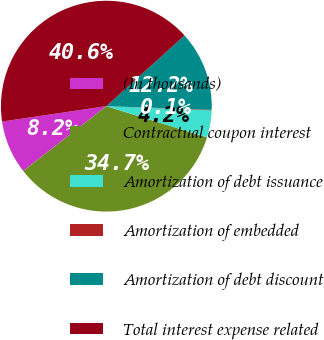Convert chart to OTSL. <chart><loc_0><loc_0><loc_500><loc_500><pie_chart><fcel>(In thousands)<fcel>Contractual coupon interest<fcel>Amortization of debt issuance<fcel>Amortization of embedded<fcel>Amortization of debt discount<fcel>Total interest expense related<nl><fcel>8.2%<fcel>34.68%<fcel>4.15%<fcel>0.09%<fcel>12.25%<fcel>40.63%<nl></chart> 